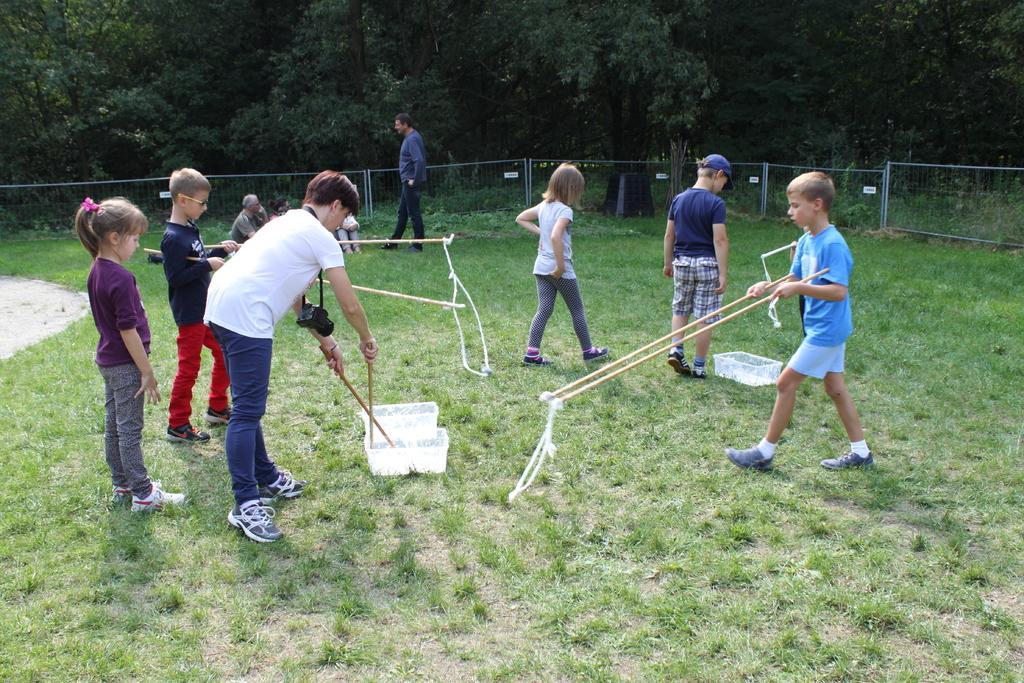How would you summarize this image in a sentence or two? In the picture we can see a grass surface on it, we can see some children are standing and holding some sticks and behind them, we can see a man walking and behind him we can see a railing and behind it we can see many trees. 